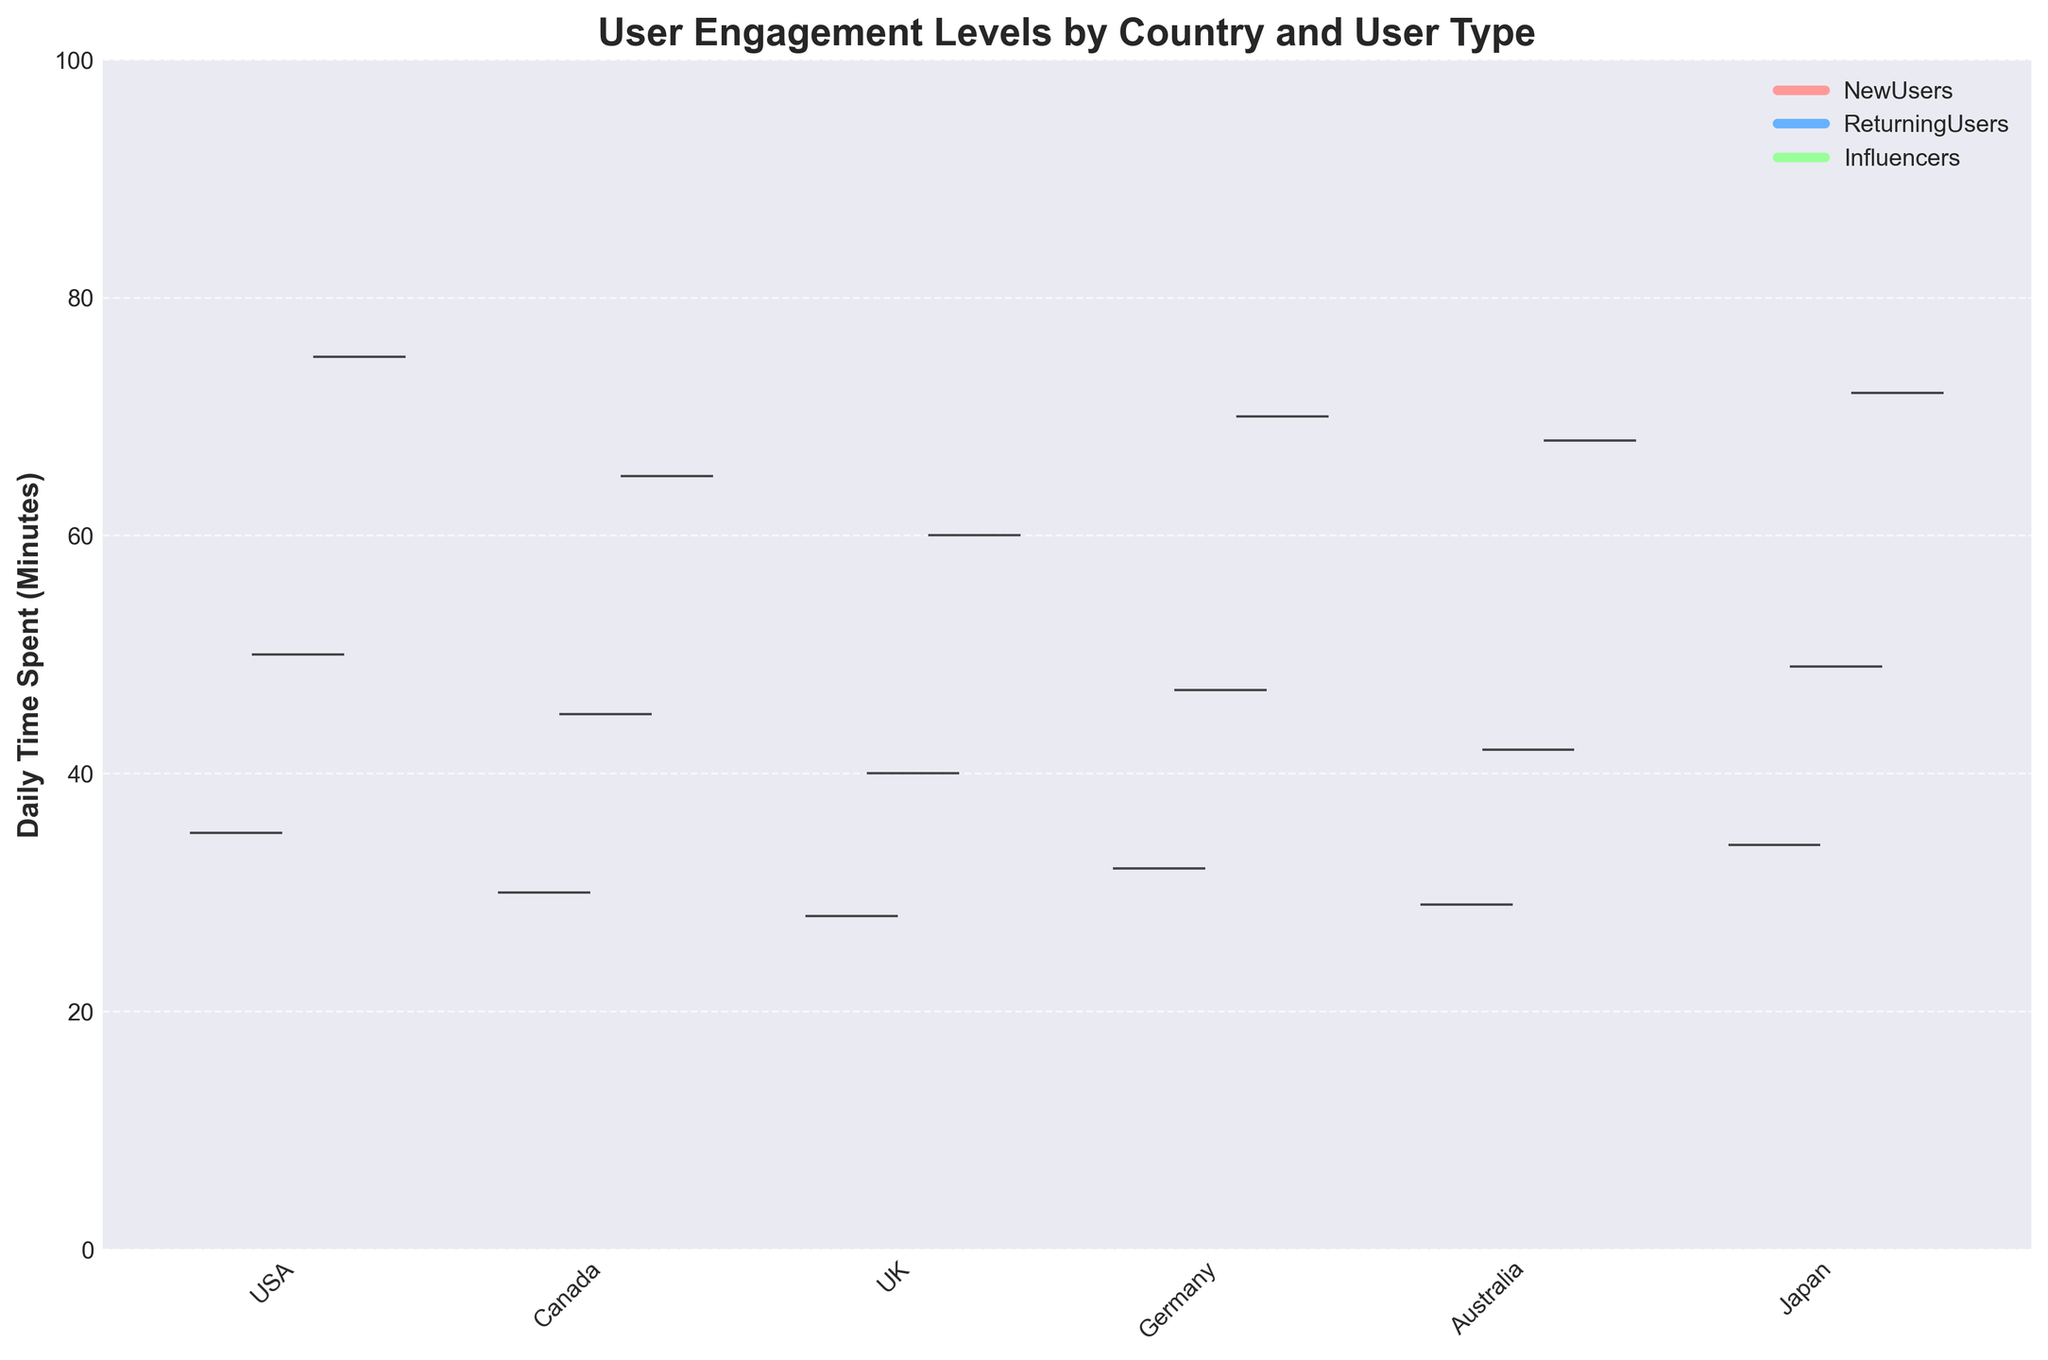What does the title of the figure say? The title of the figure is written at the top and generally provides an overview of the chart's content.
Answer: User Engagement Levels by Country and User Type What is the unit of measurement on the Y-axis? The Y-axis indicates the unit of measurement used for the data values, which helps in understanding the scale of the data.
Answer: Daily Time Spent (Minutes) Which country has the highest daily time spent for Influencers? By looking at the different colored sections in the chart, we see that Influencers in Japan have the highest daily time spent since the violin plot for this group extends the highest on the Y-axis.
Answer: Japan How do the daily time spent values for New Users in USA compare to those in Canada? By comparing the position and spread of the violin plots for New Users in the USA and Canada, we can determine which country has higher or lower engagement levels. The New Users in the USA have a higher daily time spent since the plot is higher on the Y-axis compared to Canada.
Answer: USA What can you say about the range of daily time spent for Returning Users in the UK versus Australia? By looking at the width and spread of the sections corresponding to Returning Users in the UK and Australia, we can infer that the range of daily time spent varies. The plot for Returning Users in the UK and Australia has similar heights but slightly different positions, indicating similar engagement levels.
Answer: Similar What color represents Influencers in this chart? The legend at the top right of the chart provides information on the color coding for each user type. Influencers are represented in a specific color distinct from New Users and Returning Users.
Answer: Light green Is there any country where Returning Users have the lowest daily time spent? By comparing the violin plots across all countries, we observe that Returning Users in the UK show the least daily time spent as their plot is the shortest in height on the Y-axis compared to other countries.
Answer: UK What's the difference in daily time spent between New Users and Returning Users in Germany? To find the difference, we look at the respective heights for New Users and Returning Users in Germany: New Users spend 32 minutes and Returning Users spend 47 minutes daily. The difference is 47 - 32.
Answer: 15 minutes Which user type has the most consistent daily time spent across all countries? By comparing the plot's width and spread for each user type across all countries, we see that Returning Users have plots with less variation in height, indicating more consistent engagement.
Answer: Returning Users How does New Users’ daily time spent in Japan compare to that in Germany? By comparing the height of the sections corresponding to New Users in Japan and Germany, we see that New Users in Japan have a slightly higher daily time spent than those in Germany.
Answer: Japan 